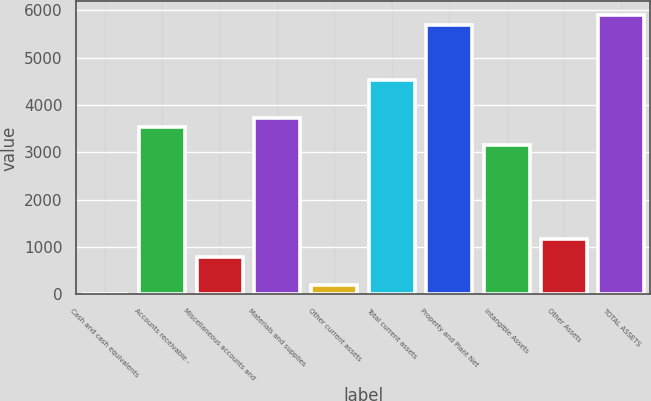Convert chart to OTSL. <chart><loc_0><loc_0><loc_500><loc_500><bar_chart><fcel>Cash and cash equivalents<fcel>Accounts receivable -<fcel>Miscellaneous accounts and<fcel>Materials and supplies<fcel>Other current assets<fcel>Total current assets<fcel>Property and Plant Net<fcel>Intangible Assets<fcel>Other Assets<fcel>TOTAL ASSETS<nl><fcel>2<fcel>3540.8<fcel>788.4<fcel>3737.4<fcel>198.6<fcel>4523.8<fcel>5703.4<fcel>3147.6<fcel>1181.6<fcel>5900<nl></chart> 